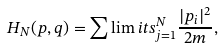<formula> <loc_0><loc_0><loc_500><loc_500>H _ { N } ( { p } , { q } ) = \sum \lim i t s _ { j = 1 } ^ { N } \frac { | p _ { i } | ^ { 2 } } { 2 m } ,</formula> 